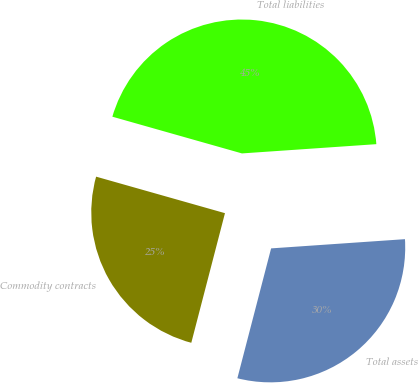Convert chart. <chart><loc_0><loc_0><loc_500><loc_500><pie_chart><fcel>Commodity contracts<fcel>Total assets<fcel>Total liabilities<nl><fcel>25.35%<fcel>30.14%<fcel>44.51%<nl></chart> 